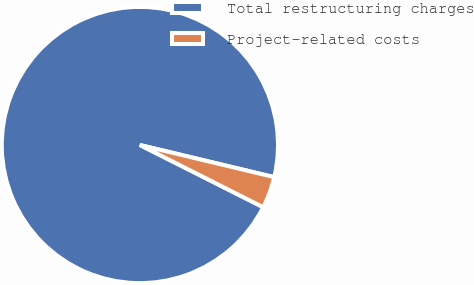Convert chart to OTSL. <chart><loc_0><loc_0><loc_500><loc_500><pie_chart><fcel>Total restructuring charges<fcel>Project-related costs<nl><fcel>96.3%<fcel>3.7%<nl></chart> 